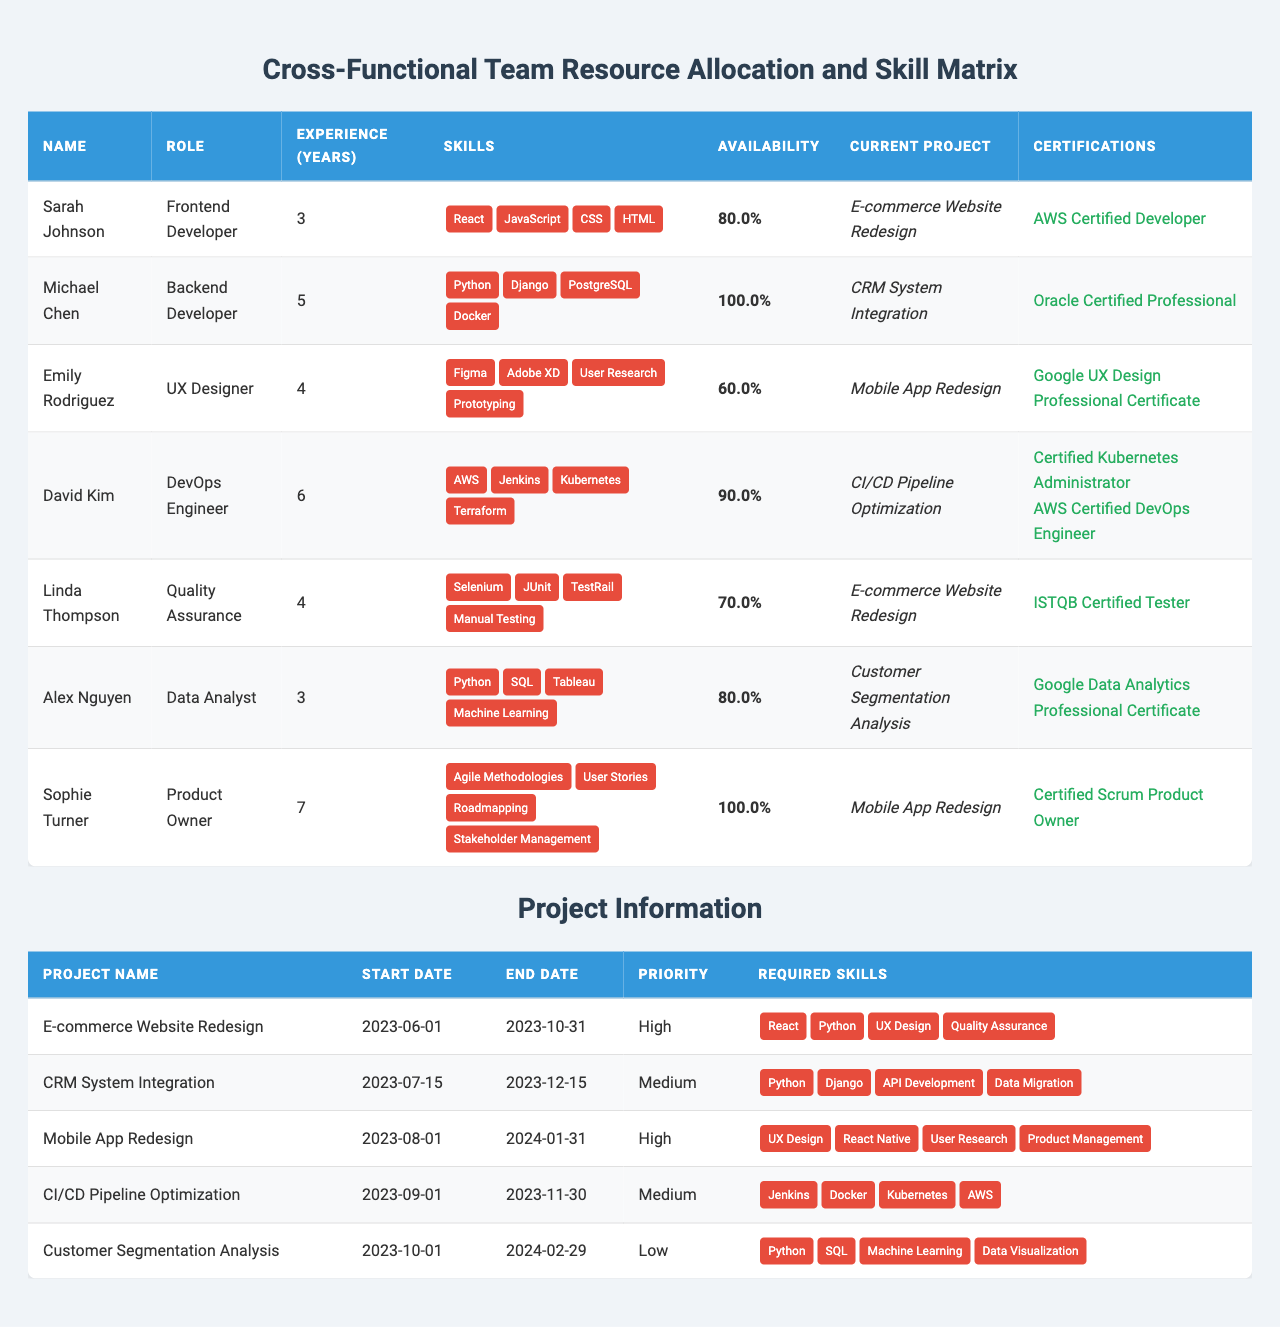What is the availability percentage of Emily Rodriguez? Emily Rodriguez's availability is listed in the table as 0.6, which means she is 60% available to work on projects.
Answer: 60% Which team member has the most experience? By comparing the 'Experience (Years)' column, David Kim has the highest experience with 6 years.
Answer: David Kim What are the required skills for the Mobile App Redesign project? The required skills for the Mobile App Redesign project can be found in its corresponding row, which lists UX Design, React Native, User Research, and Product Management.
Answer: UX Design, React Native, User Research, Product Management Is Michael Chen currently working on the E-commerce Website Redesign project? The table shows that Michael Chen is working on the CRM System Integration project, not the E-commerce Website Redesign.
Answer: No How many team members are available for the Customer Segmentation Analysis project? The skill requirements for the Customer Segmentation Analysis project are Python, SQL, Machine Learning, and Data Visualization. Alex Nguyen and Michael Chen meet these requirements. Alex is 80% available, and Michael is 100% available, making a total of 180%.
Answer: 2 What is the average experience of team members working on the Mobile App Redesign project? The team members for this project are Emily Rodriguez (4 years) and Sophie Turner (7 years). The total experience is 4 + 7 = 11 years; therefore, the average experience is 11 / 2 = 5.5 years.
Answer: 5.5 years Which project has the highest priority, and who are the team members working on it? The E-commerce Website Redesign project has the highest priority as indicated by the 'High' status. Team members working on this project are Sarah Johnson (Frontend Developer) and Linda Thompson (Quality Assurance).
Answer: E-commerce Website Redesign; Sarah Johnson and Linda Thompson What is the certification status of David Kim? David Kim has two certifications listed in the table: "Certified Kubernetes Administrator" and "AWS Certified DevOps Engineer."
Answer: 2 certifications Which role has the most team members available working at over 80% availability? By reviewing the table, we see Sarah Johnson, David Kim, and Michael Chen have over 80% availability, but David Kim is the only DevOps Engineer. Hence, the role with the most availability is shared between Frontend, DevOps, and Data Analyst.
Answer: 3 roles with over 80% availability Are there any team members with the skill "Docker"? The table indicates that Michael Chen has Docker listed among his skills, confirming that there is at least one team member with this skill.
Answer: Yes 